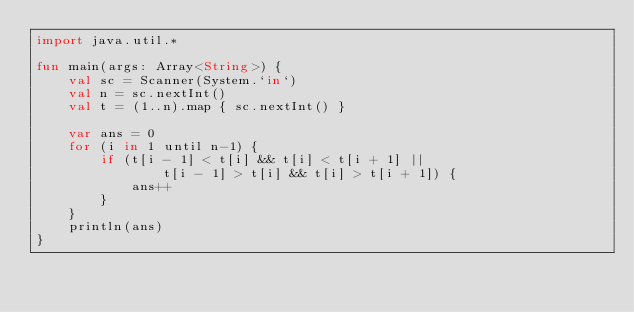Convert code to text. <code><loc_0><loc_0><loc_500><loc_500><_Kotlin_>import java.util.*

fun main(args: Array<String>) {
    val sc = Scanner(System.`in`)
    val n = sc.nextInt()
    val t = (1..n).map { sc.nextInt() }

    var ans = 0
    for (i in 1 until n-1) {
        if (t[i - 1] < t[i] && t[i] < t[i + 1] ||
                t[i - 1] > t[i] && t[i] > t[i + 1]) {
            ans++
        }
    }
    println(ans)
}</code> 